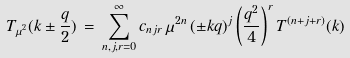Convert formula to latex. <formula><loc_0><loc_0><loc_500><loc_500>T _ { \mu ^ { 2 } } ( k \pm \frac { q } { 2 } ) \, = \, \sum _ { n , j , r = 0 } ^ { \infty } c _ { n j r } \, \mu ^ { 2 n } \, ( \pm k q ) ^ { j } \left ( \frac { q ^ { 2 } } { 4 } \right ) ^ { r } T ^ { ( n + j + r ) } ( k )</formula> 